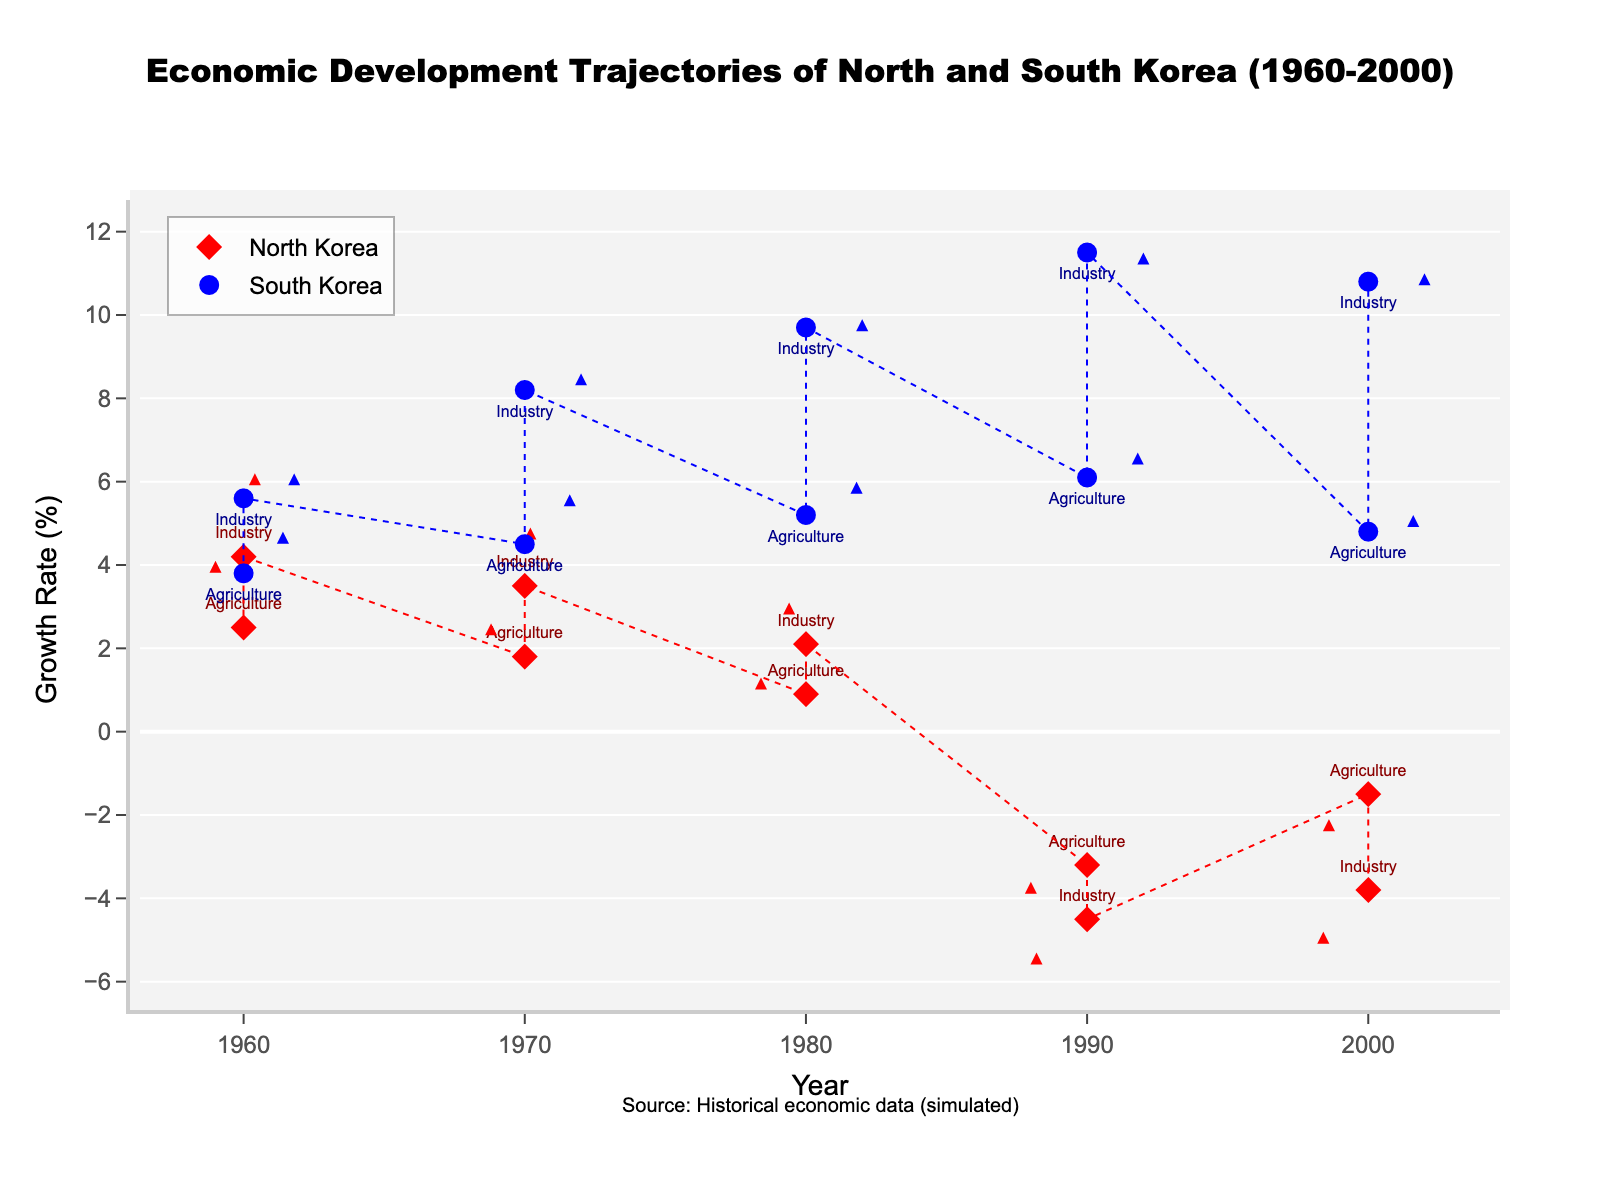What is the title of the figure? The title is located at the top of the figure and gives a summary of the data presented in the plot. From the information provided, the title is "Economic Development Trajectories of North and South Korea (1960-2000)".
Answer: Economic Development Trajectories of North and South Korea (1960-2000) Which country had a higher industry growth rate in 1970? By examining the markers and their respective labels on the plot for the year 1970, South Korea's industry growth rate is seen to be 8.2% compared to North Korea's 3.5%.
Answer: South Korea What was the growth rate for North Korea's agriculture sector in 1990? By finding the year 1990 along the x-axis and looking at the marker labeled "Agriculture" for North Korea, the growth rate is indicated to be -3.2%.
Answer: -3.2% Between North and South Korea, which country shows a downward trend in both agriculture and industry growth rates over time? North Korea shows a downward trend as both agriculture and industry sectors have declining growth rates over the decades, especially evident from the negative growth rates in 1990 and 2000 for both sectors.
Answer: North Korea What was the overall direction (upward or downward) of South Korea's industry growth rate from 1960 to 2000? Looking at the plot, South Korea's industry sector consistently shows positive growth which increases over time from 5.6% in 1960 to 11.5% in 1990, slightly dropping to 10.8% in 2000. The overall direction remains upward.
Answer: Upward In what decade did North Korea's agriculture sector first show negative growth? By analyzing the markers at each decade, North Korea's agriculture sector first shows negative growth in 1990 with a growth rate of -3.2%.
Answer: 1990 What does the direction of the arrows represent in this figure? The arrows indicate the direction and relative magnitude of sector-specific growth changes for each country. For instance, upward arrows suggest an increase in growth rate, while downward arrows indicate a decrease. The x and y components of each arrow show the overall trajectory change in two dimensions.
Answer: Sector-specific growth changes Based on the figure, which sector shows the greatest divergence in growth direction between North and South Korea by 2000? By observing the arrows and their directions in 2000, the industry sector shows the greatest divergence, with South Korea experiencing significant positive growth and North Korea showing negative growth in the opposite direction.
Answer: Industry Was there any point in time where both agriculture and industry sectors in South Korea had an equal growth rate? By analyzing the growth rates across the decades on the plot, there is no instance where the agriculture and industry sectors in South Korea had equal growth rates.
Answer: No 